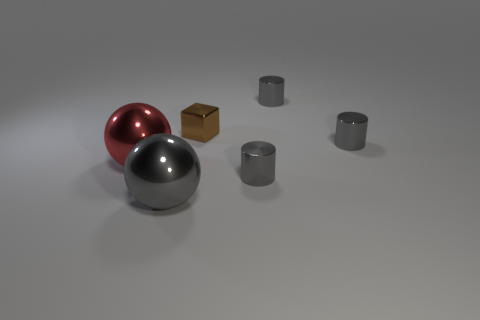How many objects are big shiny spheres or brown metallic objects?
Make the answer very short. 3. Is there any other thing that is made of the same material as the large red ball?
Ensure brevity in your answer.  Yes. Are there fewer objects behind the large red shiny object than gray metal objects?
Keep it short and to the point. Yes. Are there more large things right of the tiny brown block than gray objects that are left of the large gray metal ball?
Your answer should be very brief. No. Is there anything else of the same color as the tiny shiny block?
Keep it short and to the point. No. There is a big sphere behind the big gray ball; what material is it?
Provide a short and direct response. Metal. Do the red ball and the gray sphere have the same size?
Your answer should be very brief. Yes. How many other things are the same size as the brown metallic object?
Give a very brief answer. 3. There is a big object that is in front of the tiny gray cylinder in front of the big thing that is to the left of the big gray shiny object; what is its shape?
Provide a succinct answer. Sphere. What number of things are either gray objects behind the big red metal ball or metal objects that are right of the brown cube?
Provide a succinct answer. 3. 